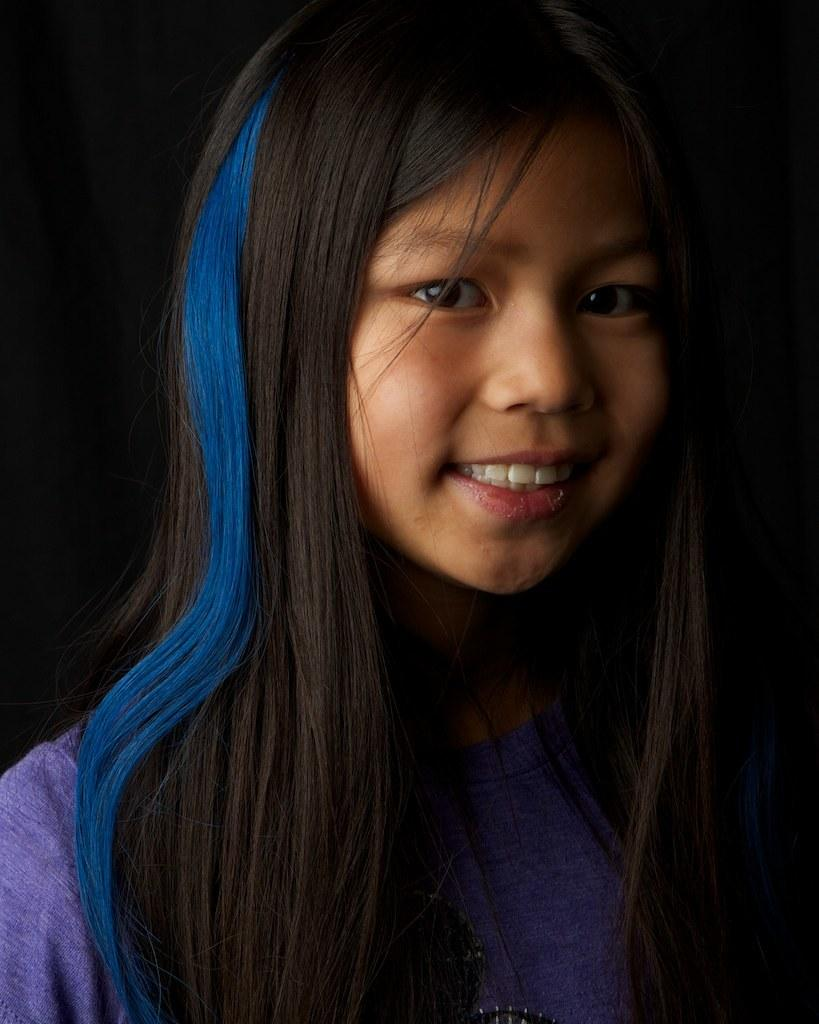What is the main subject of the image? There is a person in the image. What is the person wearing? The person is wearing a purple dress. What is the person's facial expression? The person is smiling. What color is the background of the image? The background of the image is black. Does the person in the image show any signs of regret? There is no indication of regret in the image, as the person is smiling. What type of veil is covering the person's face in the image? There is no veil present in the image; the person is wearing a purple dress. 